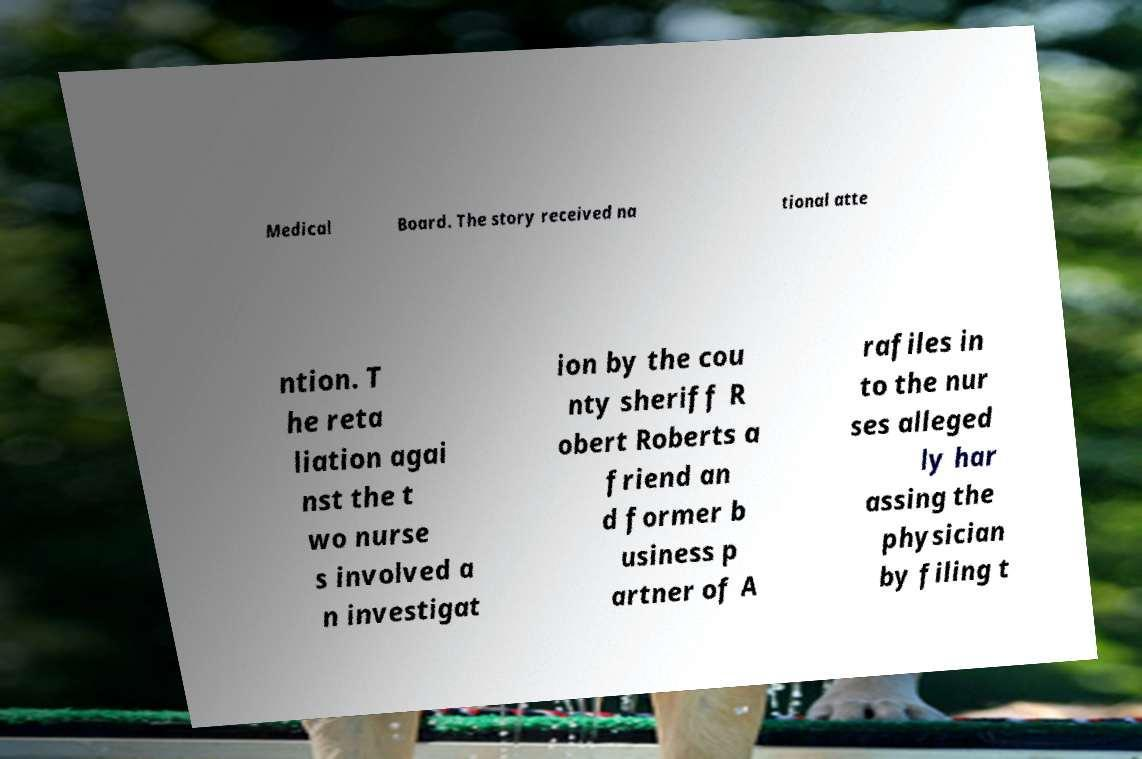Please identify and transcribe the text found in this image. Medical Board. The story received na tional atte ntion. T he reta liation agai nst the t wo nurse s involved a n investigat ion by the cou nty sheriff R obert Roberts a friend an d former b usiness p artner of A rafiles in to the nur ses alleged ly har assing the physician by filing t 